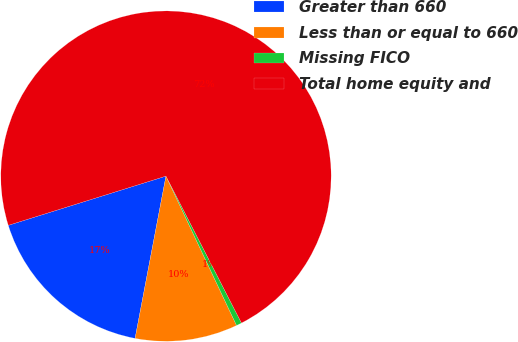Convert chart to OTSL. <chart><loc_0><loc_0><loc_500><loc_500><pie_chart><fcel>Greater than 660<fcel>Less than or equal to 660<fcel>Missing FICO<fcel>Total home equity and<nl><fcel>17.19%<fcel>10.02%<fcel>0.53%<fcel>72.26%<nl></chart> 